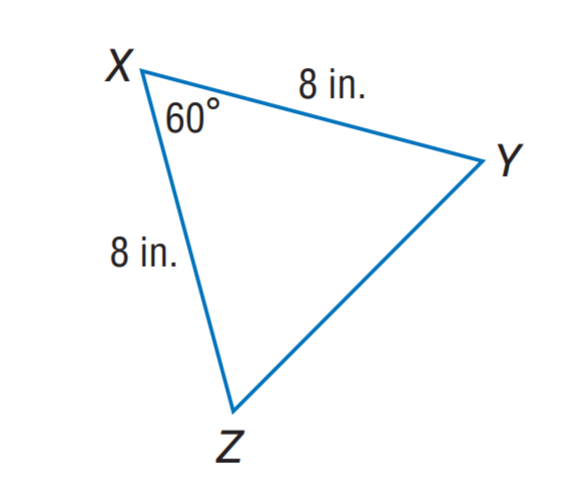Question: Find m \angle Y.
Choices:
A. 50
B. 60
C. 70
D. 80
Answer with the letter. Answer: B Question: Find Y Z.
Choices:
A. 6
B. 7
C. 8
D. 9
Answer with the letter. Answer: C 